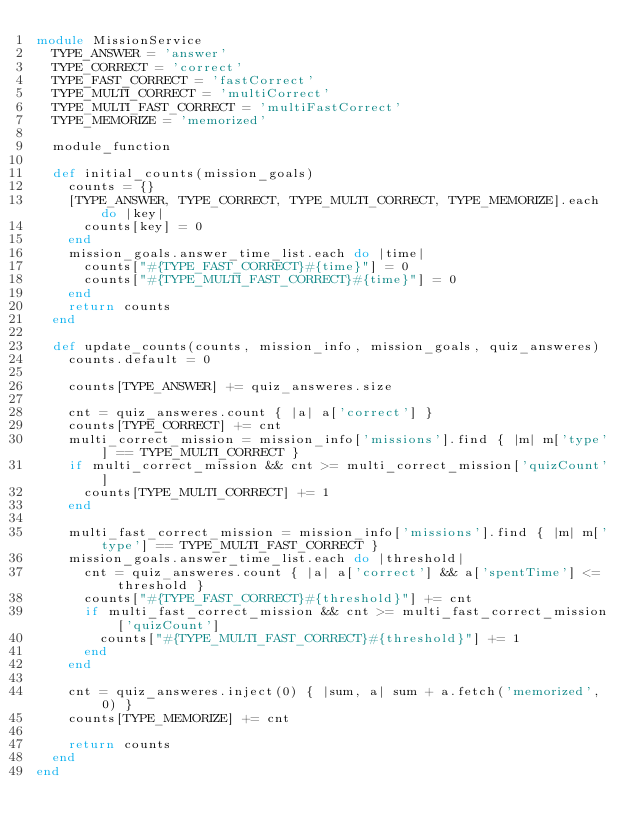Convert code to text. <code><loc_0><loc_0><loc_500><loc_500><_Ruby_>module MissionService
  TYPE_ANSWER = 'answer'
  TYPE_CORRECT = 'correct'
  TYPE_FAST_CORRECT = 'fastCorrect'
  TYPE_MULTI_CORRECT = 'multiCorrect'
  TYPE_MULTI_FAST_CORRECT = 'multiFastCorrect'
  TYPE_MEMORIZE = 'memorized'

  module_function

  def initial_counts(mission_goals)
    counts = {}
    [TYPE_ANSWER, TYPE_CORRECT, TYPE_MULTI_CORRECT, TYPE_MEMORIZE].each do |key|
      counts[key] = 0
    end
    mission_goals.answer_time_list.each do |time|
      counts["#{TYPE_FAST_CORRECT}#{time}"] = 0
      counts["#{TYPE_MULTI_FAST_CORRECT}#{time}"] = 0
    end
    return counts
  end

  def update_counts(counts, mission_info, mission_goals, quiz_answeres)
    counts.default = 0

    counts[TYPE_ANSWER] += quiz_answeres.size

    cnt = quiz_answeres.count { |a| a['correct'] }
    counts[TYPE_CORRECT] += cnt
    multi_correct_mission = mission_info['missions'].find { |m| m['type'] == TYPE_MULTI_CORRECT }
    if multi_correct_mission && cnt >= multi_correct_mission['quizCount']
      counts[TYPE_MULTI_CORRECT] += 1
    end

    multi_fast_correct_mission = mission_info['missions'].find { |m| m['type'] == TYPE_MULTI_FAST_CORRECT }
    mission_goals.answer_time_list.each do |threshold|
      cnt = quiz_answeres.count { |a| a['correct'] && a['spentTime'] <= threshold }
      counts["#{TYPE_FAST_CORRECT}#{threshold}"] += cnt
      if multi_fast_correct_mission && cnt >= multi_fast_correct_mission['quizCount']
        counts["#{TYPE_MULTI_FAST_CORRECT}#{threshold}"] += 1
      end
    end

    cnt = quiz_answeres.inject(0) { |sum, a| sum + a.fetch('memorized', 0) }
    counts[TYPE_MEMORIZE] += cnt

    return counts
  end
end
</code> 